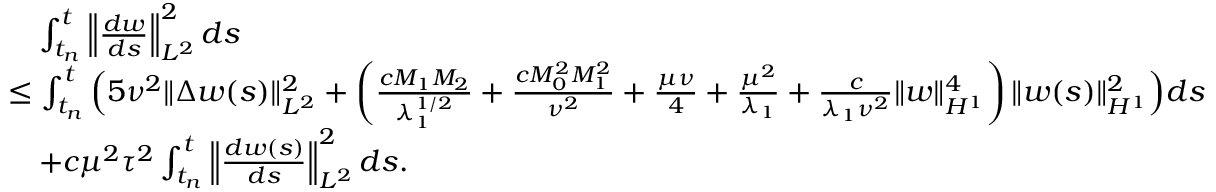<formula> <loc_0><loc_0><loc_500><loc_500>\begin{array} { r l } & { \quad \int _ { t _ { n } } ^ { t } \left \| \frac { d w } { d s } \right \| _ { L ^ { 2 } } ^ { 2 } d s } \\ & { \leq \int _ { t _ { n } } ^ { t } \left ( 5 \nu ^ { 2 } \| \Delta w ( s ) \| _ { L ^ { 2 } } ^ { 2 } + \left ( \frac { c M _ { 1 } M _ { 2 } } { \lambda _ { 1 } ^ { 1 / 2 } } + \frac { c M _ { 0 } ^ { 2 } M _ { 1 } ^ { 2 } } { \nu ^ { 2 } } + \frac { \mu \nu } { 4 } + \frac { \mu ^ { 2 } } { \lambda _ { 1 } } + \frac { c } { \lambda _ { 1 } \nu ^ { 2 } } \| w \| _ { H ^ { 1 } } ^ { 4 } \right ) \| w ( s ) \| _ { H ^ { 1 } } ^ { 2 } \right ) d s } \\ & { \quad + c \mu ^ { 2 } \tau ^ { 2 } \int _ { t _ { n } } ^ { t } \left \| \frac { d w ( s ) } { d s } \right \| _ { L ^ { 2 } } ^ { 2 } d s . } \end{array}</formula> 